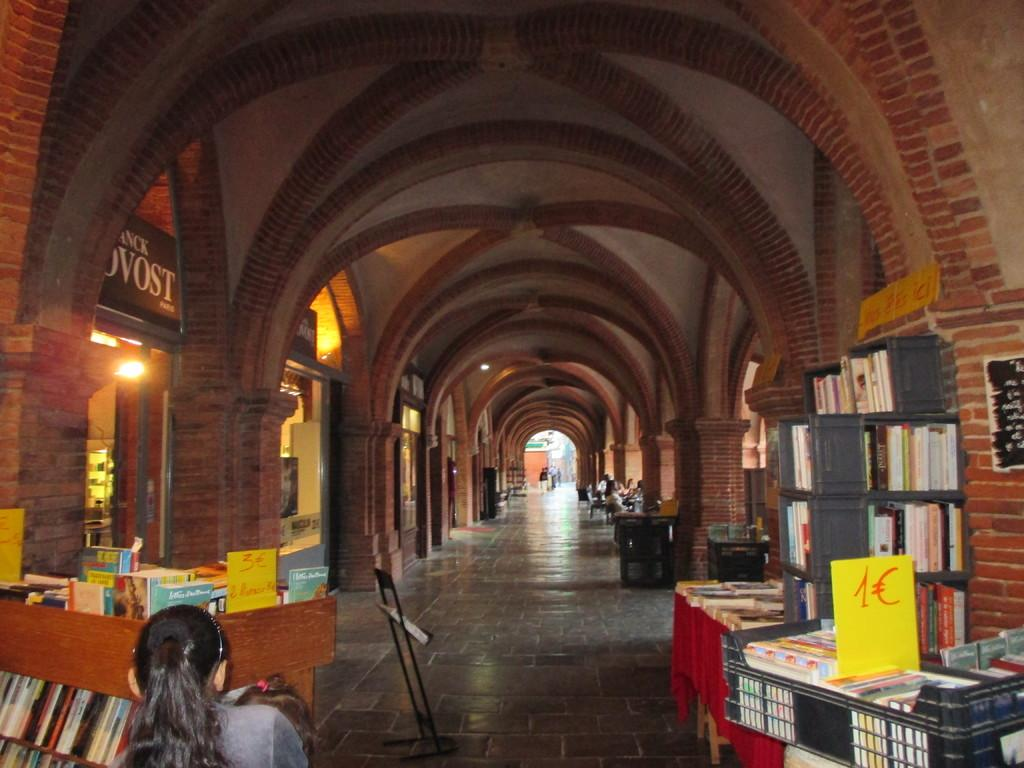<image>
Present a compact description of the photo's key features. a long hall and a piece of paper with 1C on it 